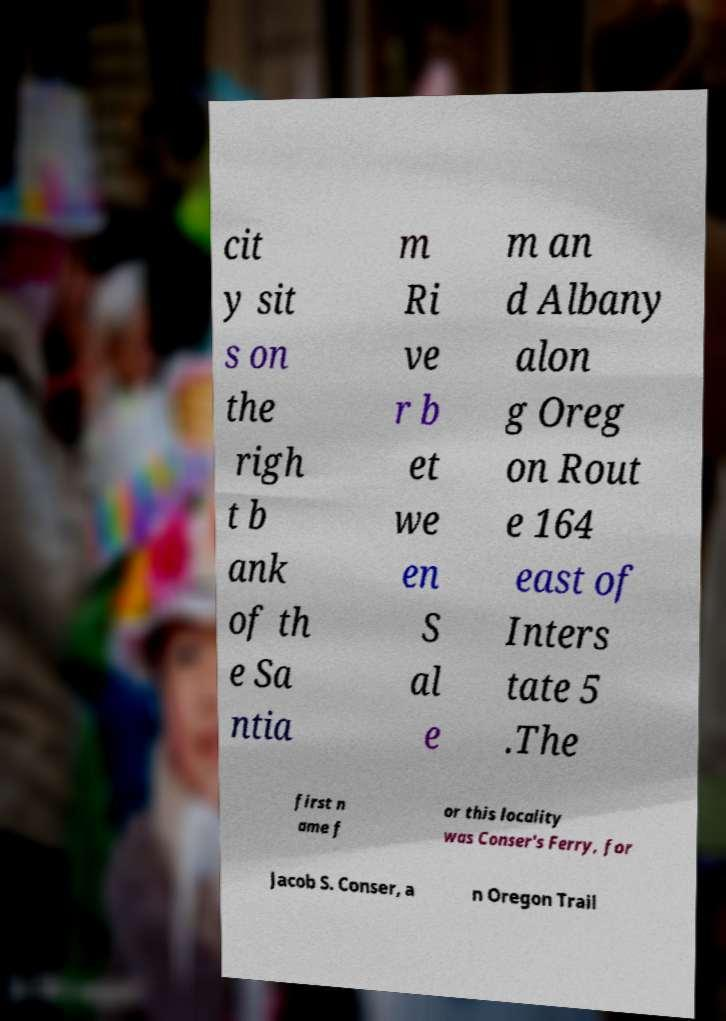What messages or text are displayed in this image? I need them in a readable, typed format. cit y sit s on the righ t b ank of th e Sa ntia m Ri ve r b et we en S al e m an d Albany alon g Oreg on Rout e 164 east of Inters tate 5 .The first n ame f or this locality was Conser's Ferry, for Jacob S. Conser, a n Oregon Trail 